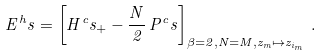<formula> <loc_0><loc_0><loc_500><loc_500>E ^ { h } s = \left [ H ^ { c } s _ { + } - \frac { N } { 2 } \, { P } ^ { c } s \right ] _ { \beta = 2 , N = M , z _ { m } \mapsto z _ { i _ { m } } } \, .</formula> 